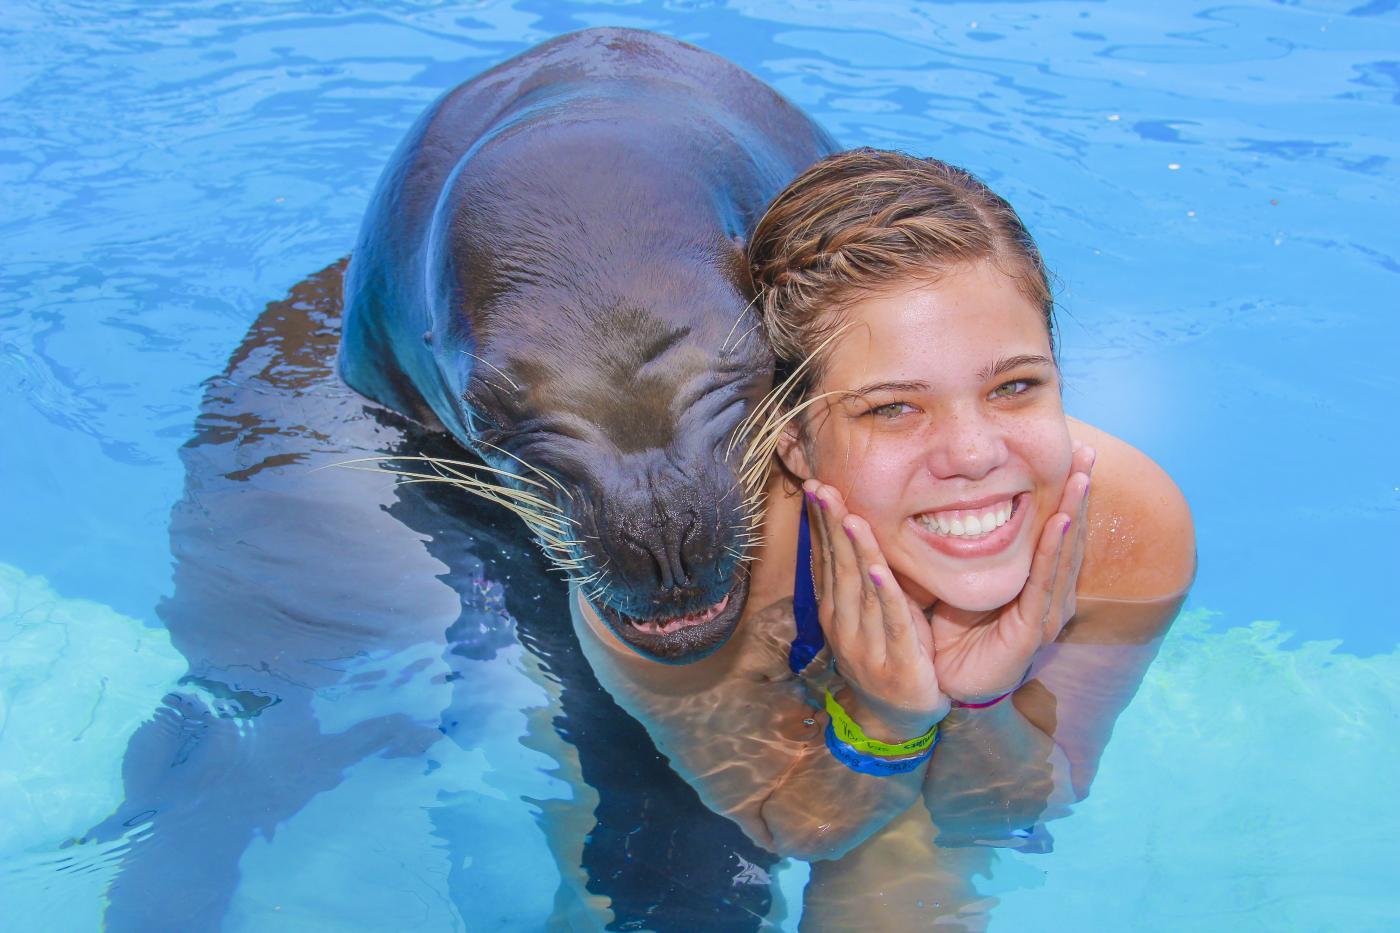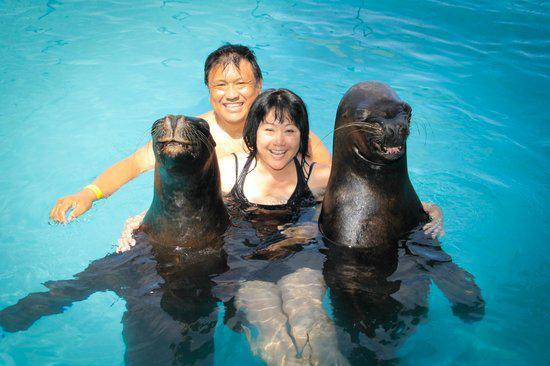The first image is the image on the left, the second image is the image on the right. Considering the images on both sides, is "Two people are in the water with two sea animals in one of the pictures." valid? Answer yes or no. Yes. The first image is the image on the left, the second image is the image on the right. Given the left and right images, does the statement "The right image includes twice the number of people and seals in the foreground as the left image." hold true? Answer yes or no. Yes. 